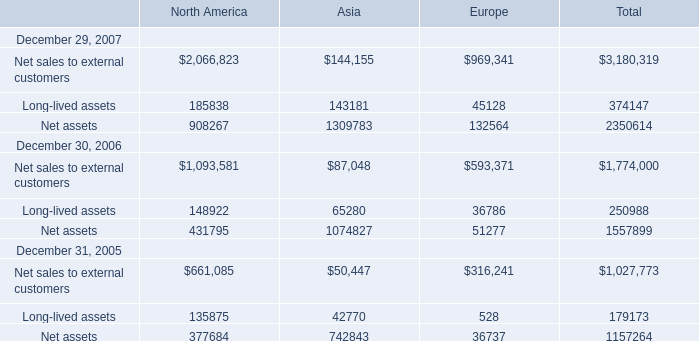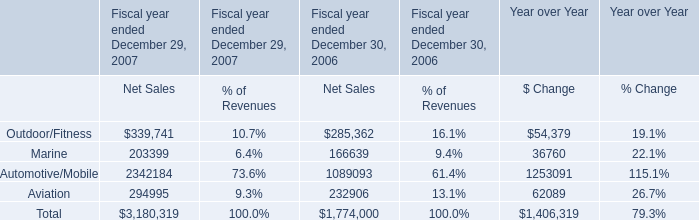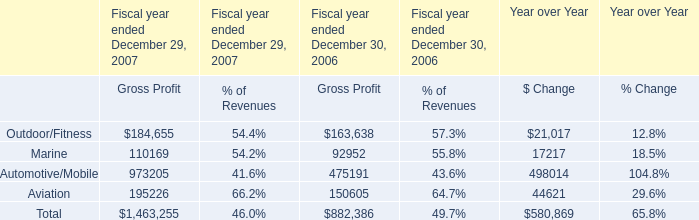Which element makes up more than 70% of total for Asia in 2006? 
Answer: Net sales to external customers, Net assets. 